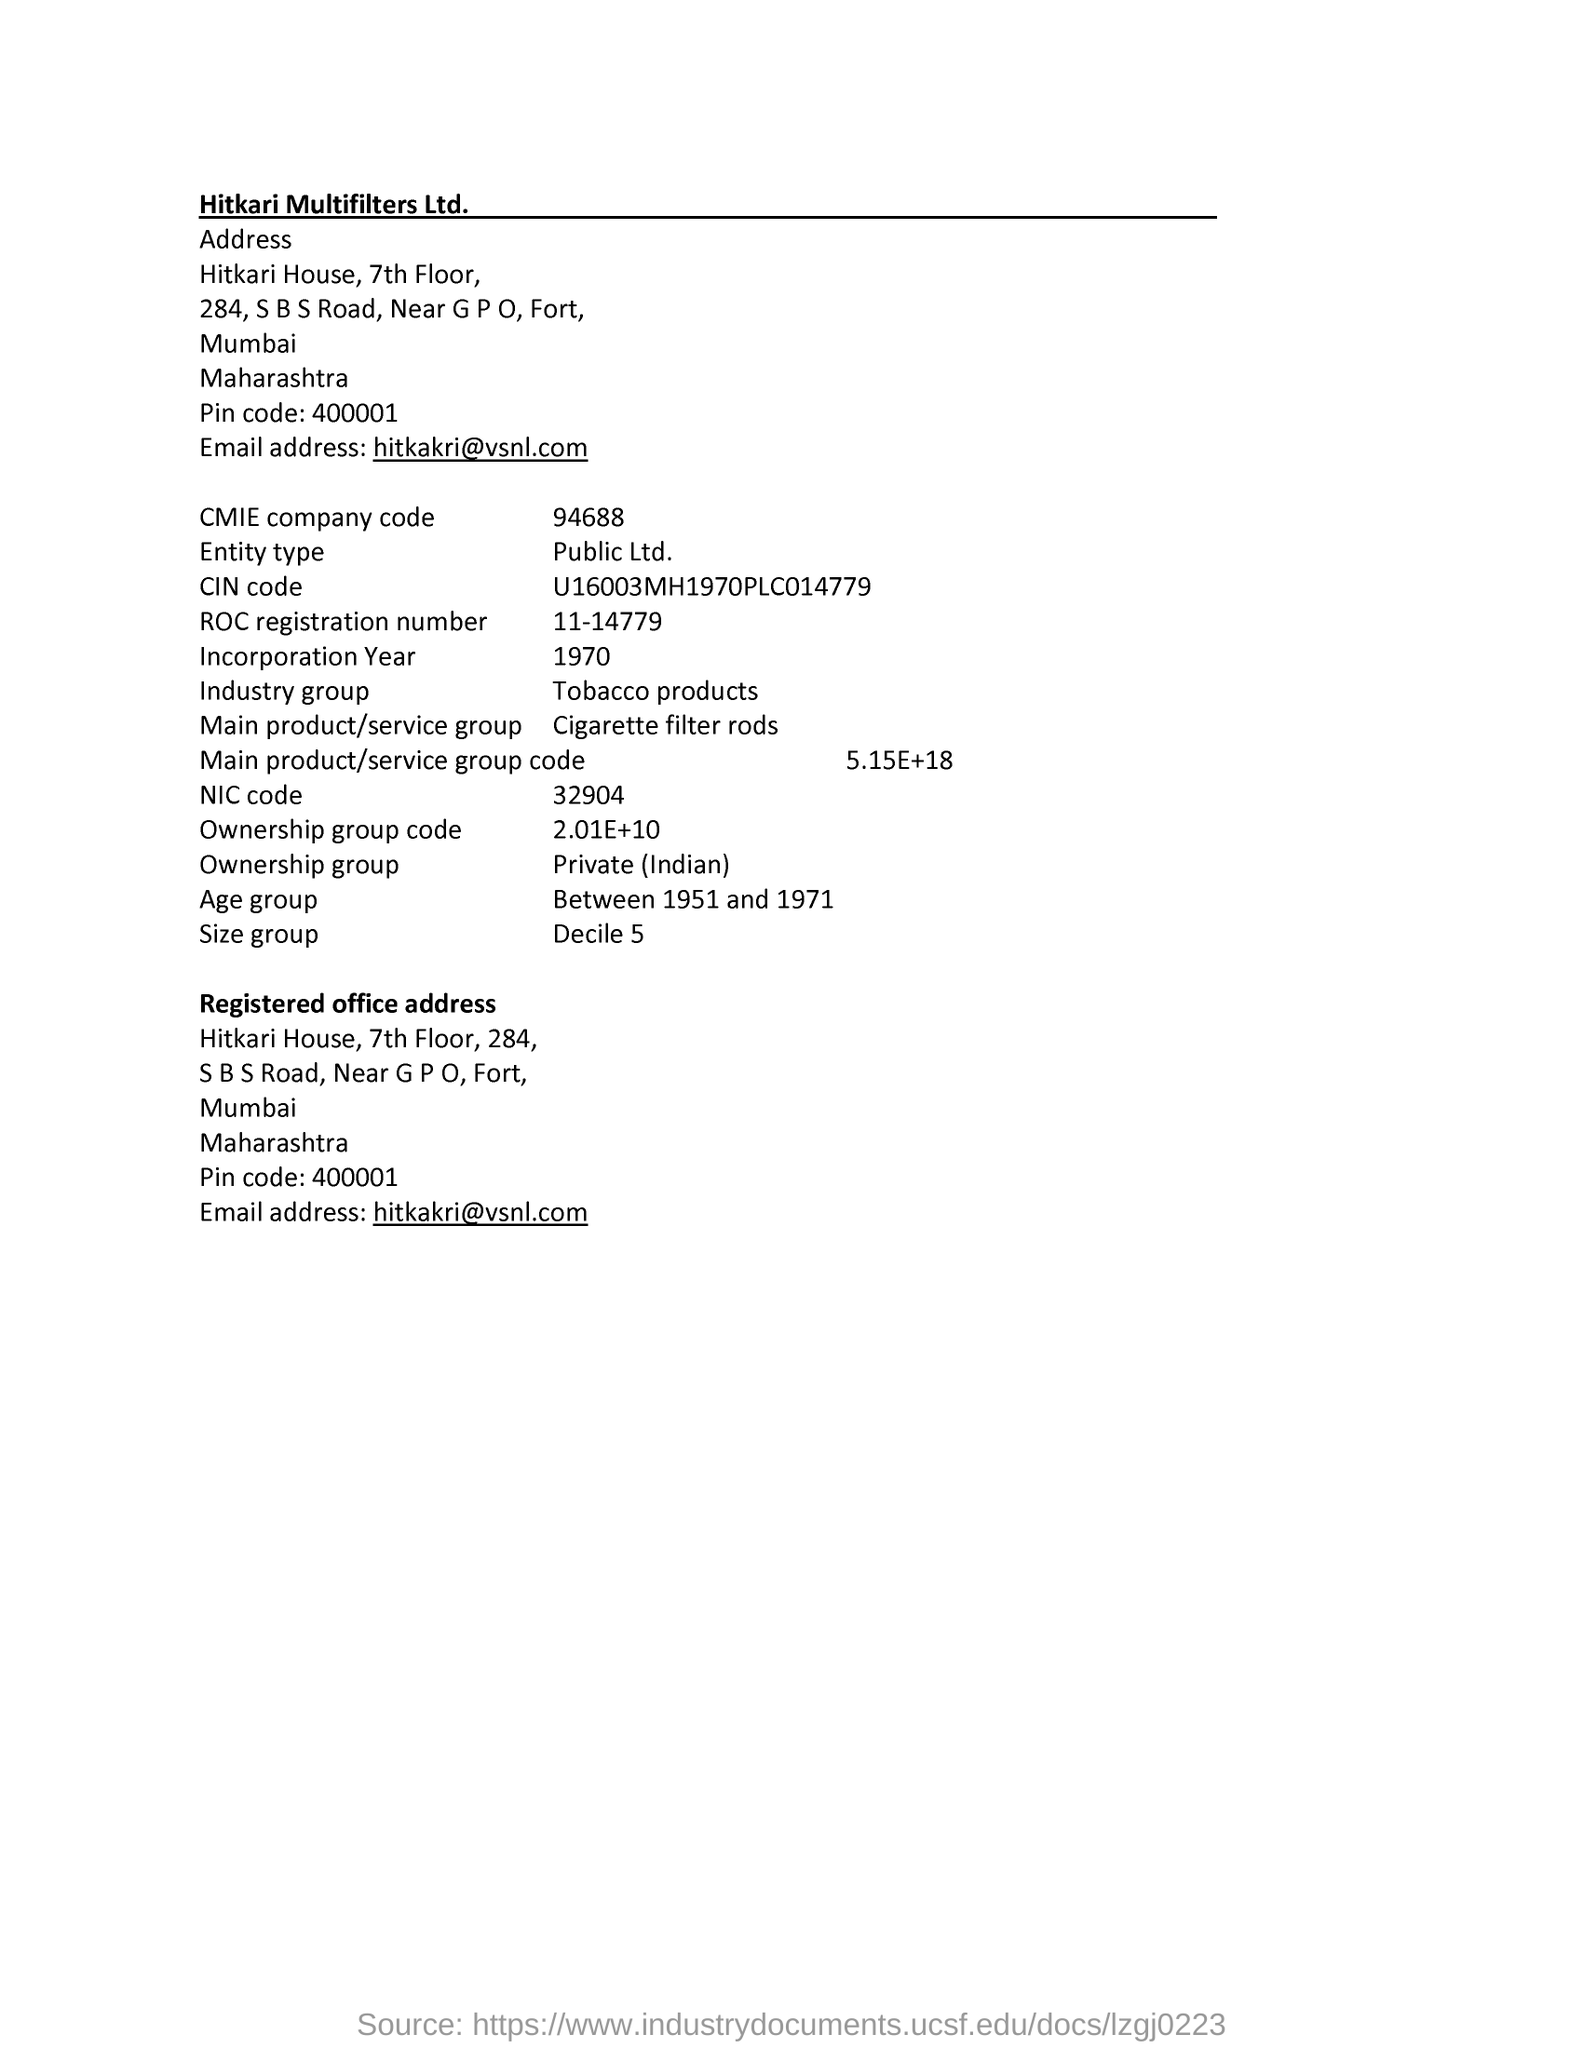Identify some key points in this picture. Hitkari Multifilters Ltd.'s email address is [vsnl.com](mailto:vsnl.com). The CMIE company code is 94688. What is the Registration of Occupation Certificate number? It is 11-14779. The Ownership Group Code is a specific number, which is approximately 2.01E+10. The NIC code is 32904. 